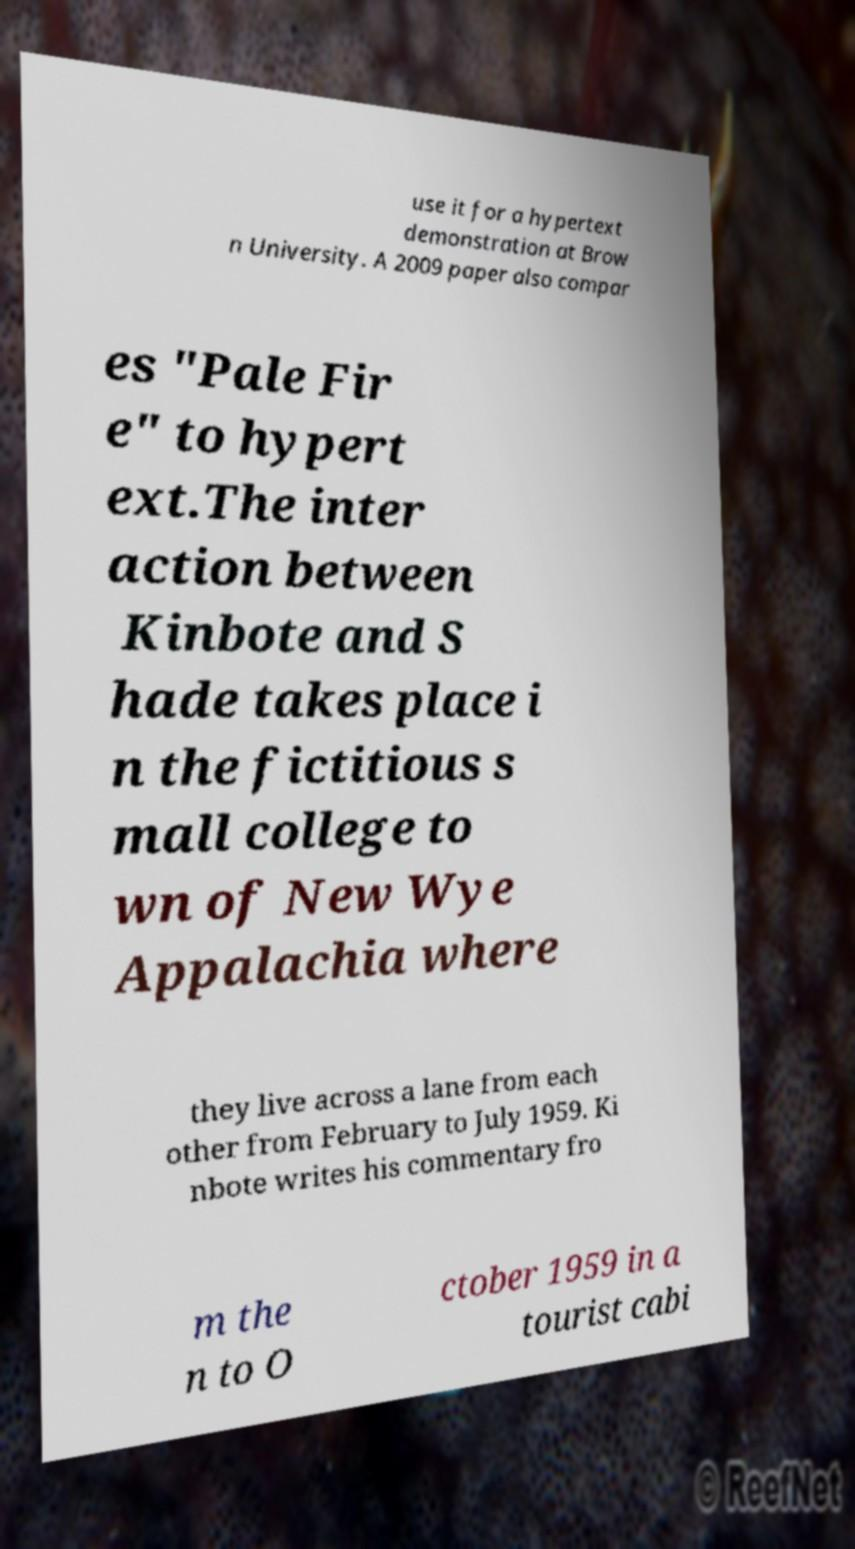Can you accurately transcribe the text from the provided image for me? use it for a hypertext demonstration at Brow n University. A 2009 paper also compar es "Pale Fir e" to hypert ext.The inter action between Kinbote and S hade takes place i n the fictitious s mall college to wn of New Wye Appalachia where they live across a lane from each other from February to July 1959. Ki nbote writes his commentary fro m the n to O ctober 1959 in a tourist cabi 